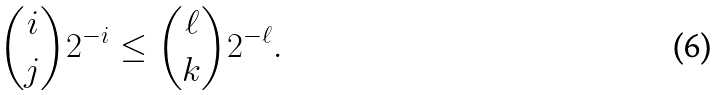Convert formula to latex. <formula><loc_0><loc_0><loc_500><loc_500>\binom { i } { j } 2 ^ { - i } \leq \binom { \ell } { k } 2 ^ { - \ell } .</formula> 